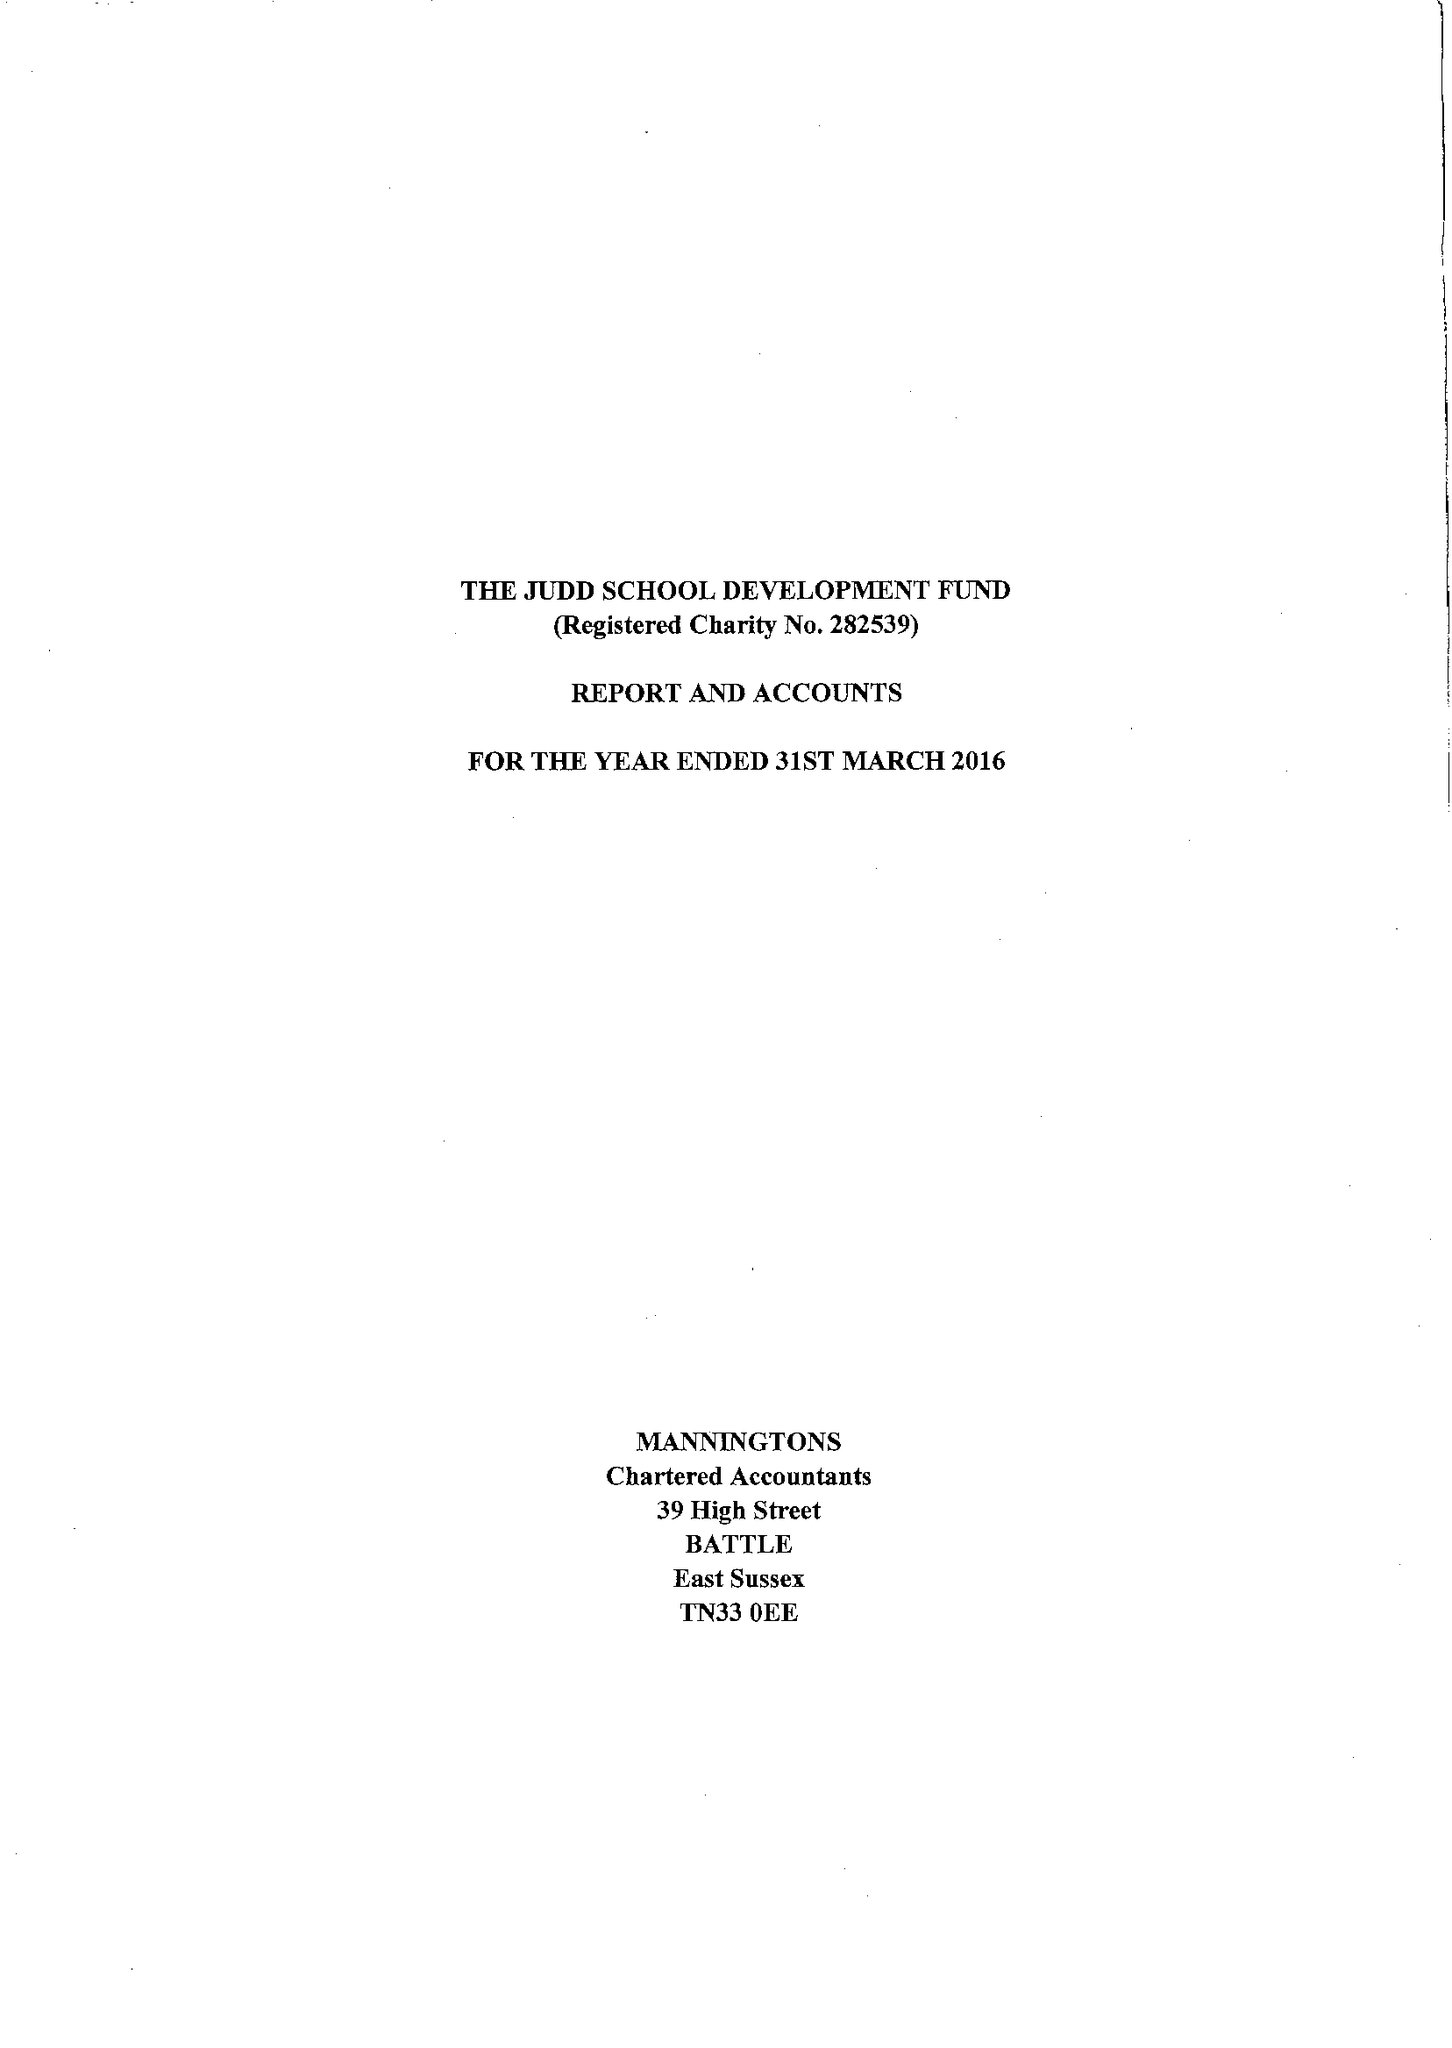What is the value for the report_date?
Answer the question using a single word or phrase. 2016-03-31 